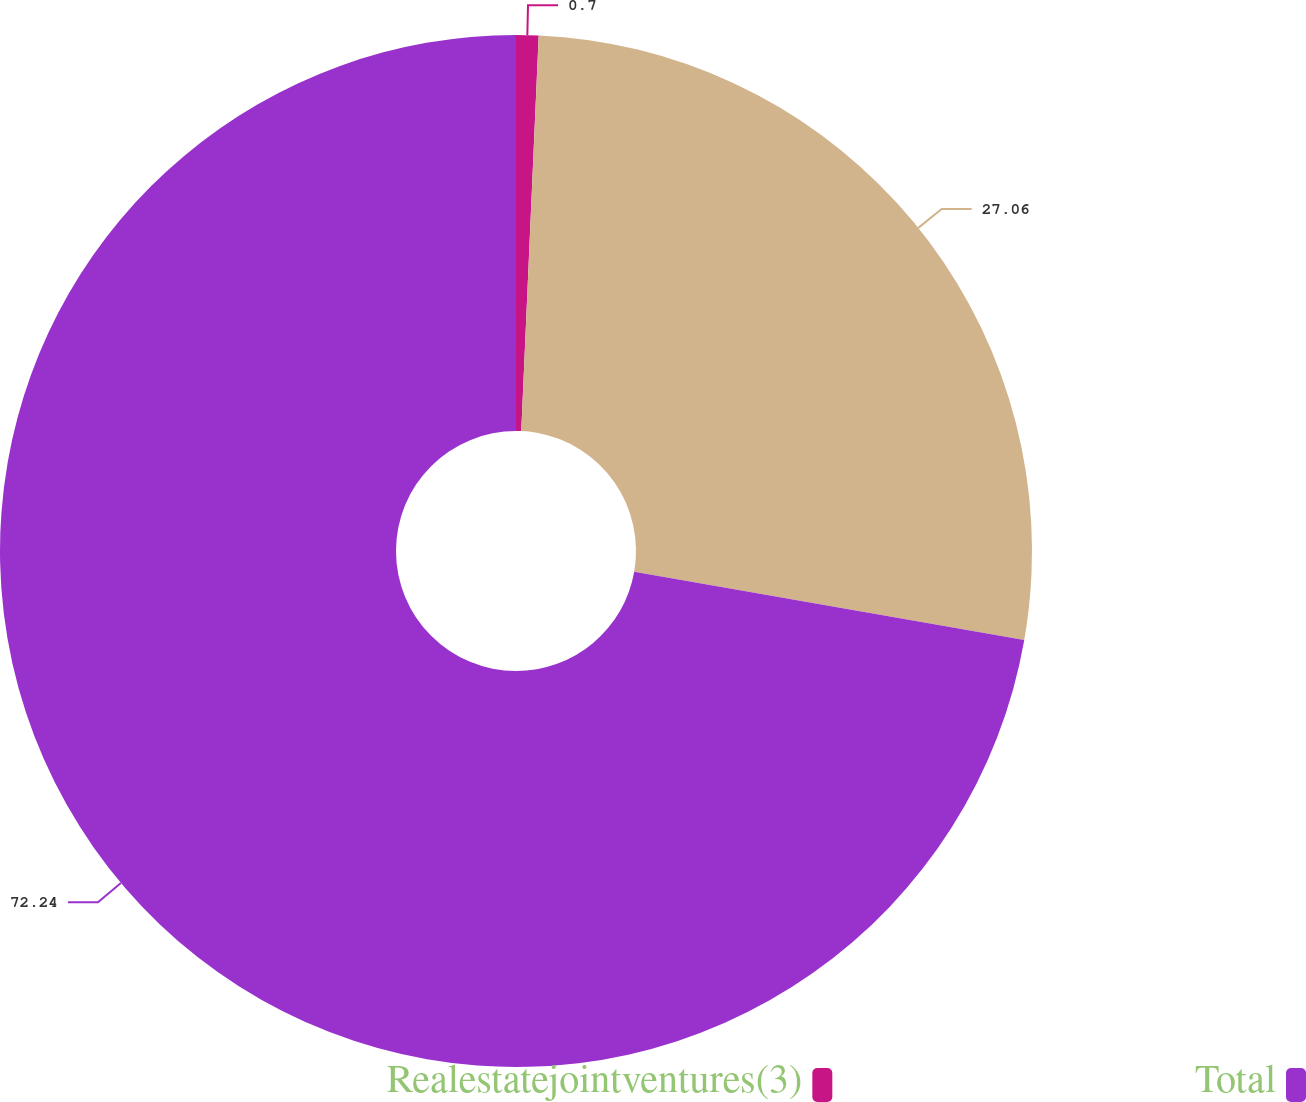Convert chart to OTSL. <chart><loc_0><loc_0><loc_500><loc_500><pie_chart><fcel>Realestatejointventures(3)<fcel>Unnamed: 1<fcel>Total<nl><fcel>0.7%<fcel>27.06%<fcel>72.24%<nl></chart> 